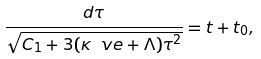Convert formula to latex. <formula><loc_0><loc_0><loc_500><loc_500>\frac { d \tau } { \sqrt { C _ { 1 } + 3 ( \kappa \ v e + \Lambda ) \tau ^ { 2 } } } = t + t _ { 0 } ,</formula> 